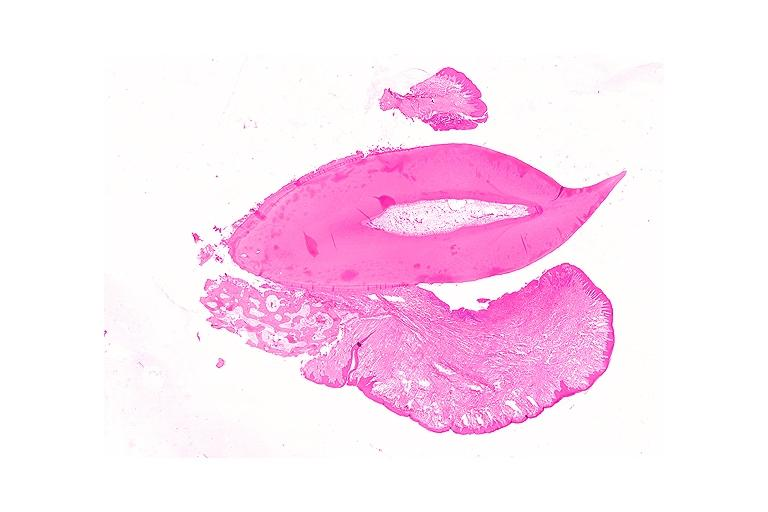s oral present?
Answer the question using a single word or phrase. Yes 